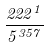Convert formula to latex. <formula><loc_0><loc_0><loc_500><loc_500>\frac { 2 2 2 ^ { 1 } } { 5 ^ { 3 5 7 } }</formula> 